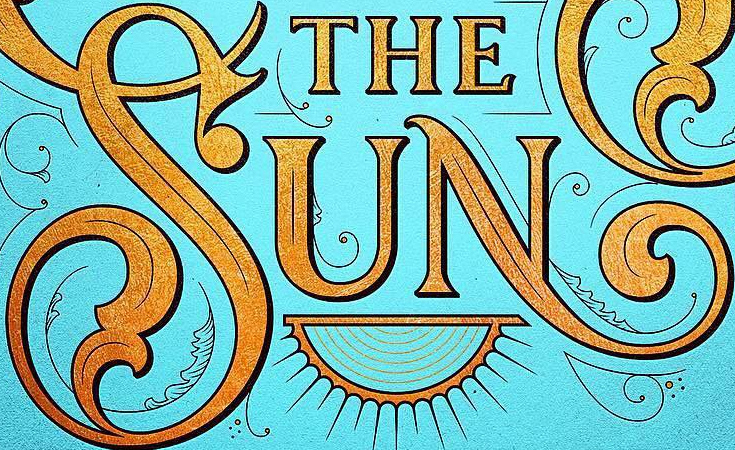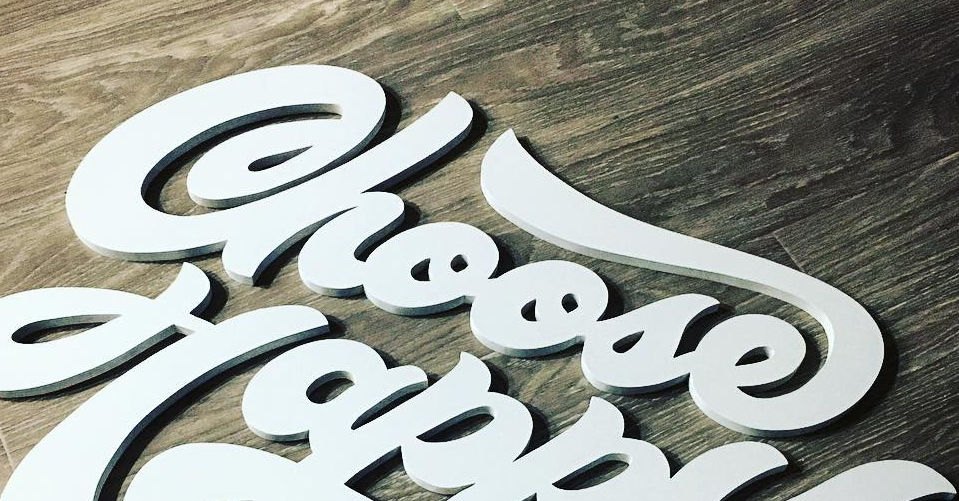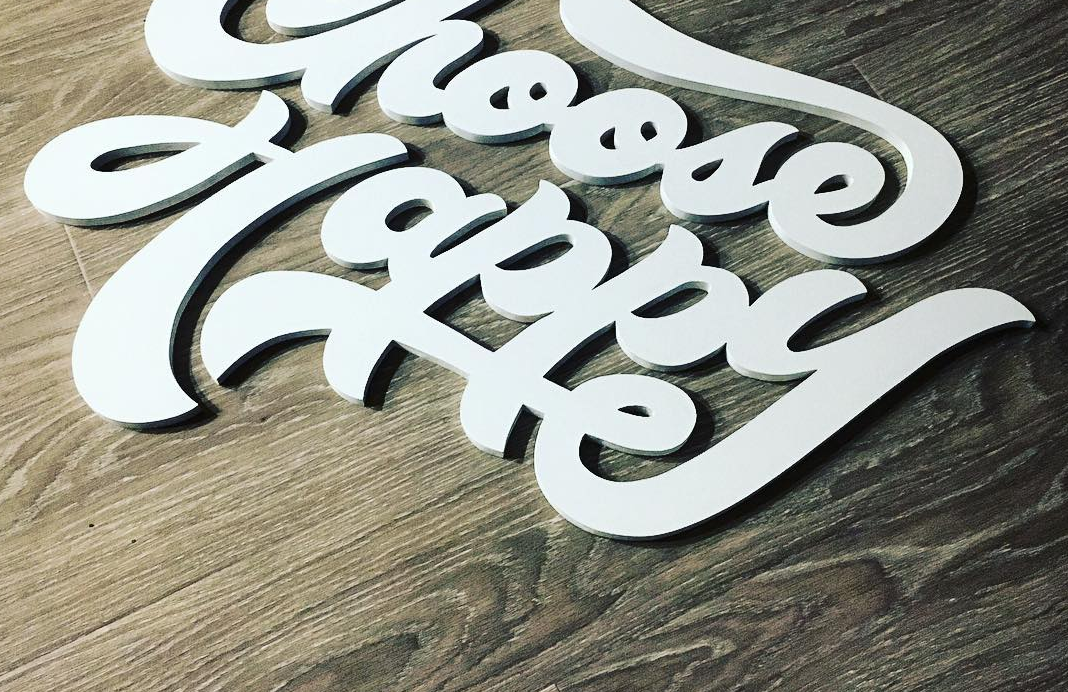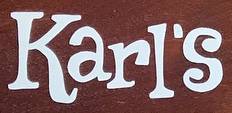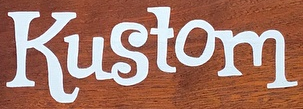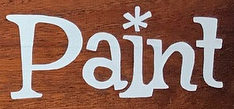Identify the words shown in these images in order, separated by a semicolon. SUN; Choose; Happy; Karl's; Kustom; Paint 